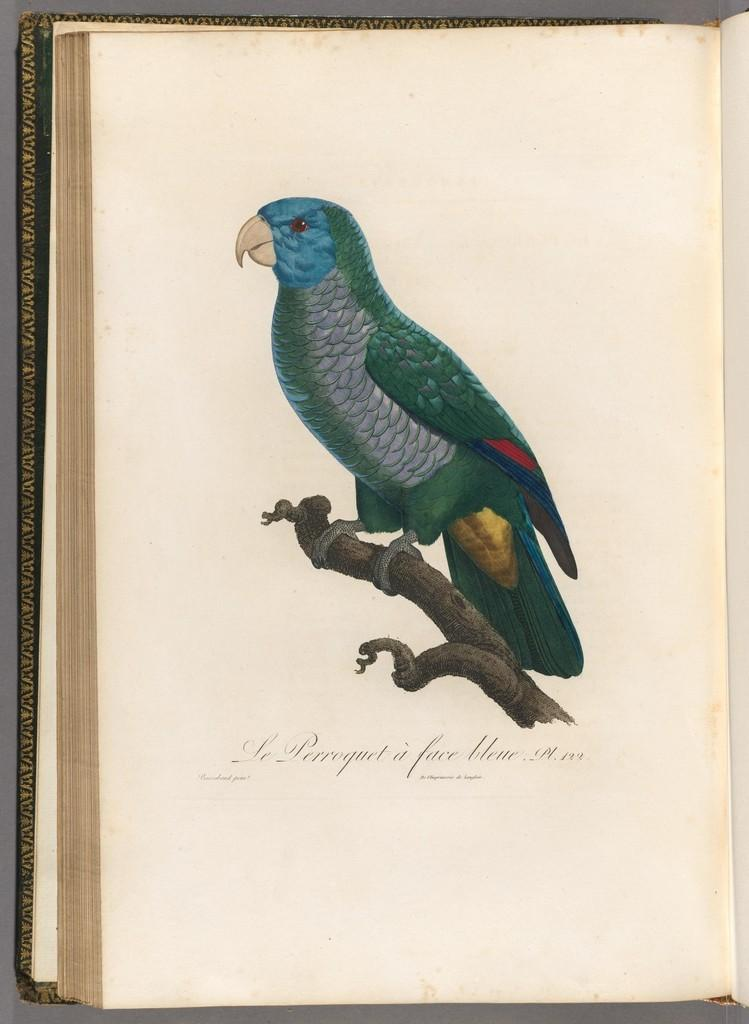What is the main object in the image? There is a book in the image. What type of artwork is present in the image? There is a painting of a bird in the image. How is the bird depicted in the painting? The bird in the painting is on a stem. What can be found at the bottom of the image? There is text at the bottom of the image. How many wings does the bird in the painting have? The bird in the painting does not have any wings; it is depicted on a stem. Are there any snakes visible in the image? There are no snakes present in the image; it features a book and a painting of a bird on a stem. 